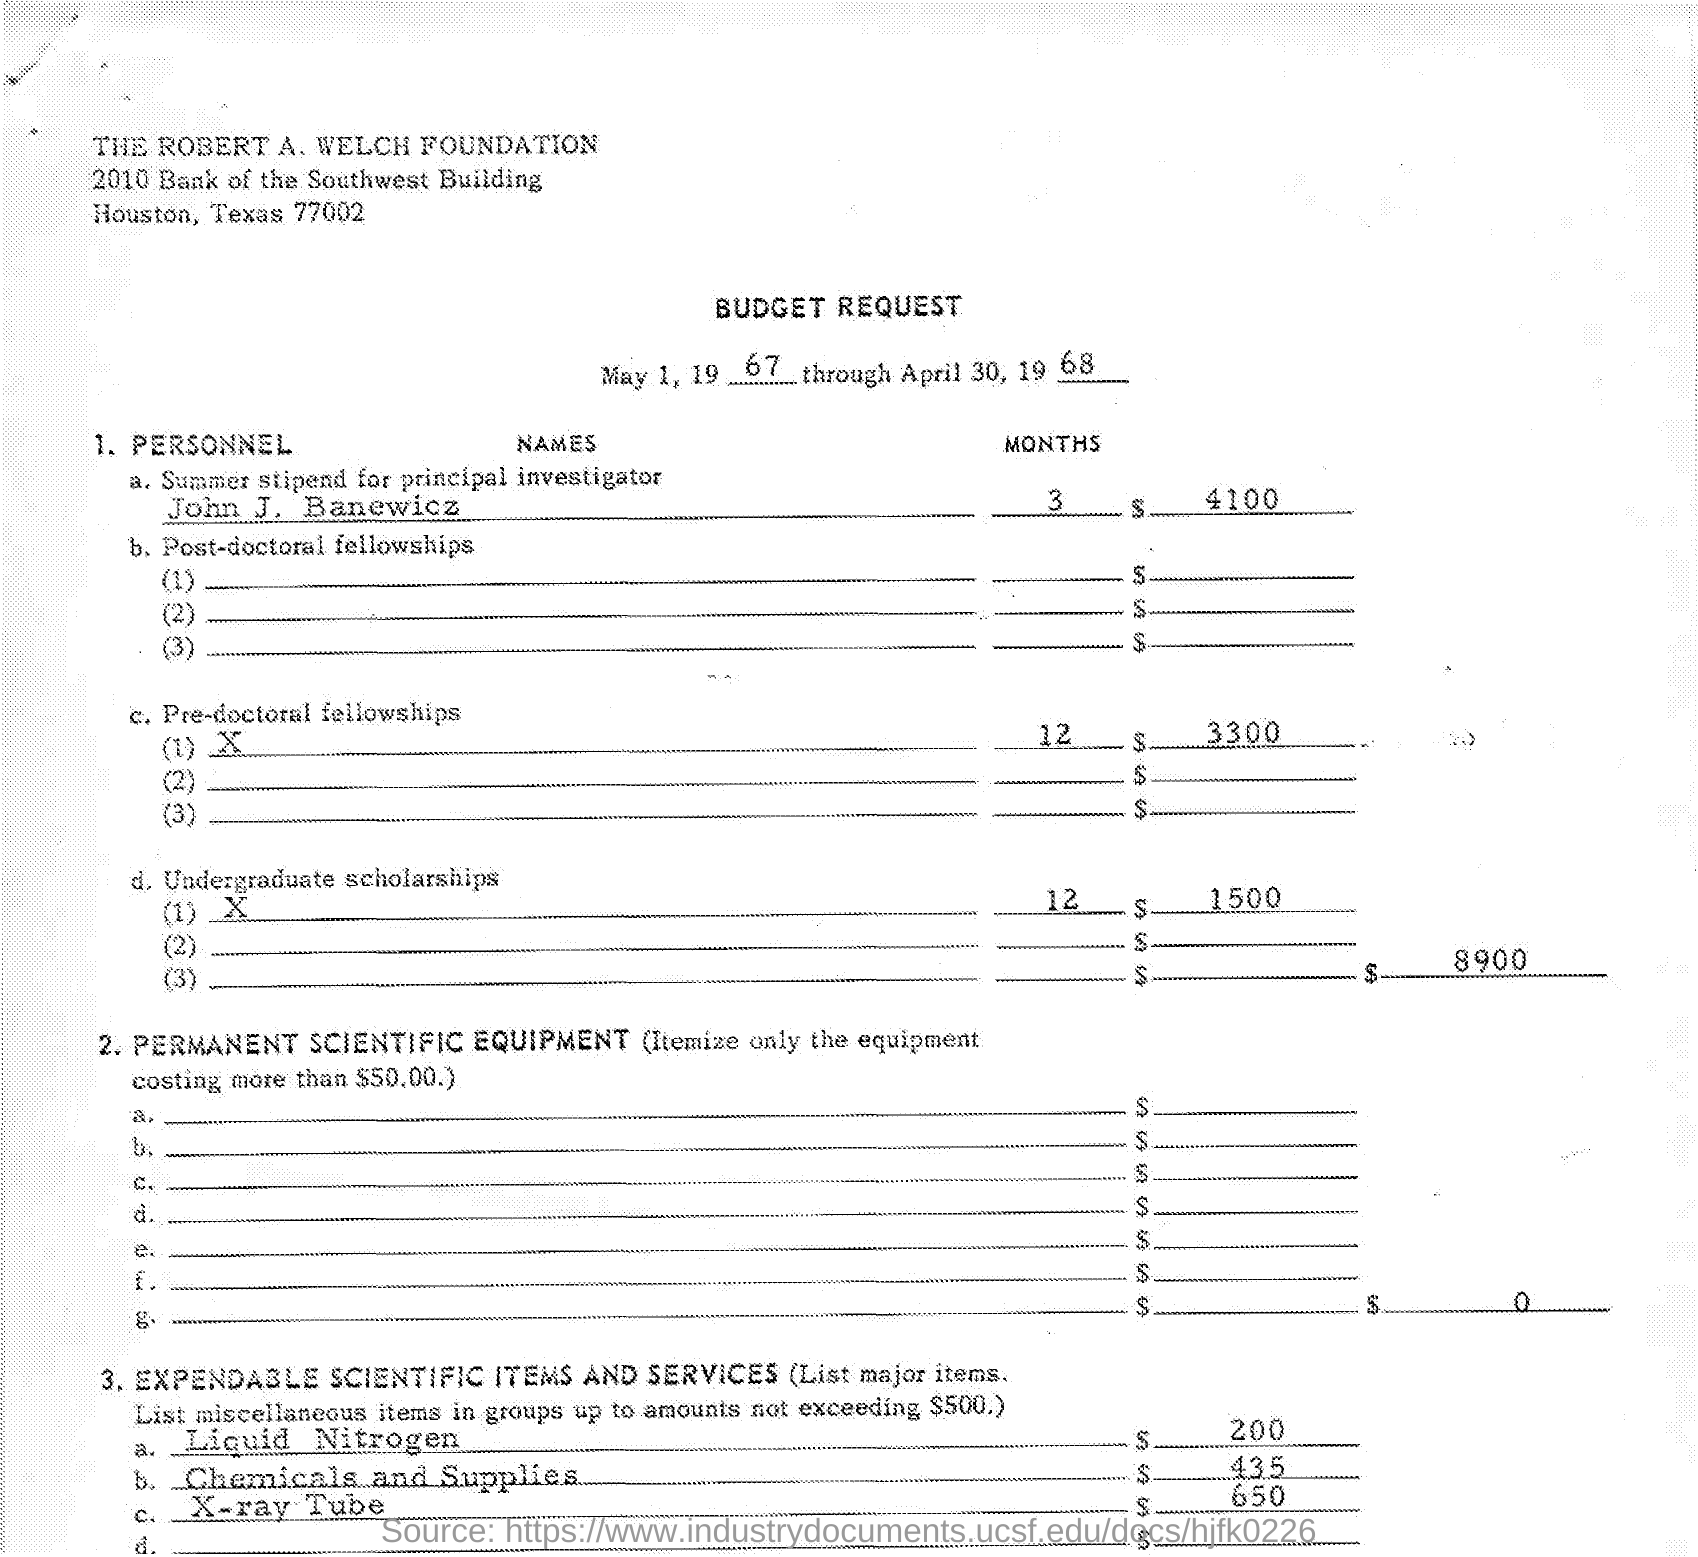Mention a couple of crucial points in this snapshot. The cost of Liquid Nitrogen is approximately $200. The cost of chemicals and supplies is $435. The document contains a date range of May 1, 1967 through April 30, 1968. The summer stipend for John J. Banewicz is $4,100. The principal investigator is John J. Baneiwicz. 